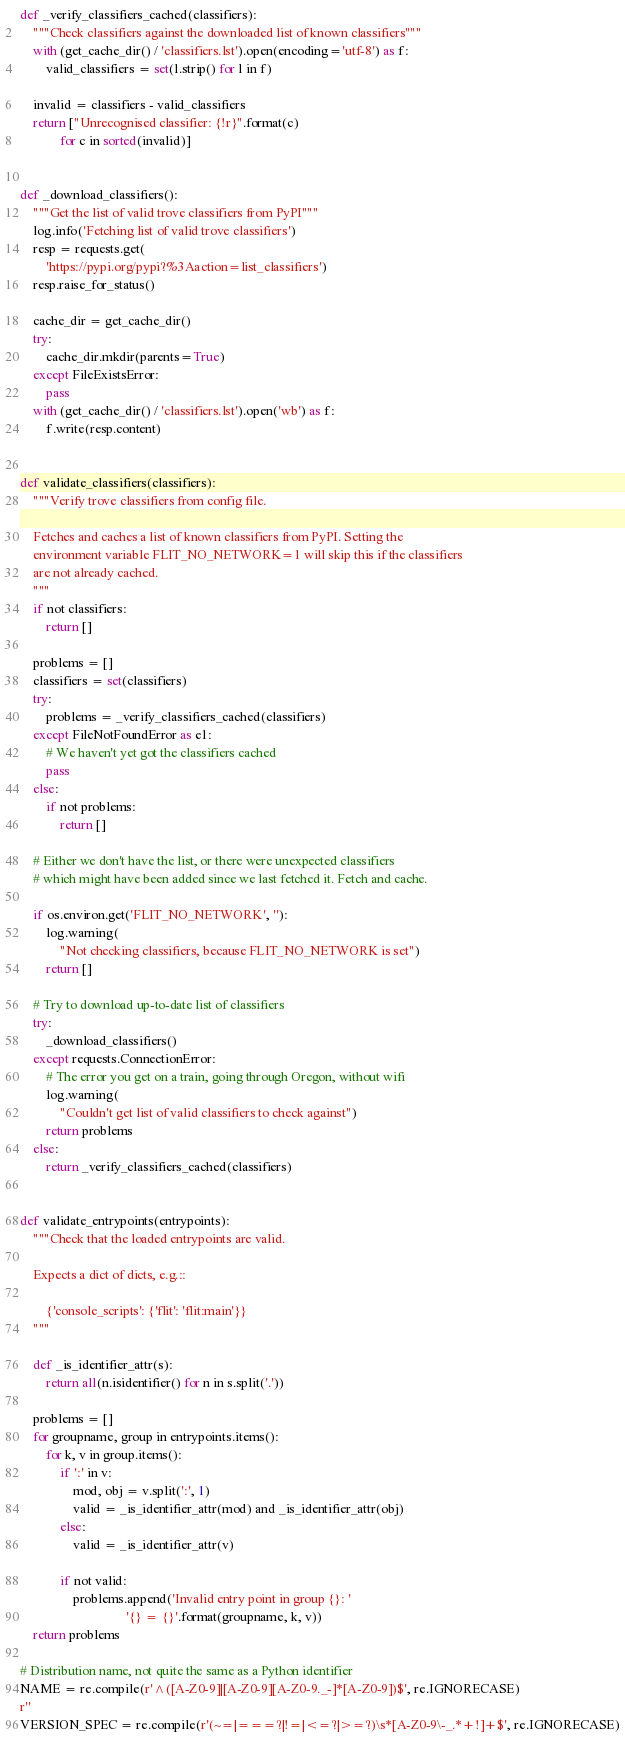Convert code to text. <code><loc_0><loc_0><loc_500><loc_500><_Python_>def _verify_classifiers_cached(classifiers):
    """Check classifiers against the downloaded list of known classifiers"""
    with (get_cache_dir() / 'classifiers.lst').open(encoding='utf-8') as f:
        valid_classifiers = set(l.strip() for l in f)

    invalid = classifiers - valid_classifiers
    return ["Unrecognised classifier: {!r}".format(c)
            for c in sorted(invalid)]


def _download_classifiers():
    """Get the list of valid trove classifiers from PyPI"""
    log.info('Fetching list of valid trove classifiers')
    resp = requests.get(
        'https://pypi.org/pypi?%3Aaction=list_classifiers')
    resp.raise_for_status()

    cache_dir = get_cache_dir()
    try:
        cache_dir.mkdir(parents=True)
    except FileExistsError:
        pass
    with (get_cache_dir() / 'classifiers.lst').open('wb') as f:
        f.write(resp.content)


def validate_classifiers(classifiers):
    """Verify trove classifiers from config file.

    Fetches and caches a list of known classifiers from PyPI. Setting the
    environment variable FLIT_NO_NETWORK=1 will skip this if the classifiers
    are not already cached.
    """
    if not classifiers:
        return []

    problems = []
    classifiers = set(classifiers)
    try:
        problems = _verify_classifiers_cached(classifiers)
    except FileNotFoundError as e1:
        # We haven't yet got the classifiers cached
        pass
    else:
        if not problems:
            return []

    # Either we don't have the list, or there were unexpected classifiers
    # which might have been added since we last fetched it. Fetch and cache.

    if os.environ.get('FLIT_NO_NETWORK', ''):
        log.warning(
            "Not checking classifiers, because FLIT_NO_NETWORK is set")
        return []

    # Try to download up-to-date list of classifiers
    try:
        _download_classifiers()
    except requests.ConnectionError:
        # The error you get on a train, going through Oregon, without wifi
        log.warning(
            "Couldn't get list of valid classifiers to check against")
        return problems
    else:
        return _verify_classifiers_cached(classifiers)


def validate_entrypoints(entrypoints):
    """Check that the loaded entrypoints are valid.

    Expects a dict of dicts, e.g.::

        {'console_scripts': {'flit': 'flit:main'}}
    """

    def _is_identifier_attr(s):
        return all(n.isidentifier() for n in s.split('.'))

    problems = []
    for groupname, group in entrypoints.items():
        for k, v in group.items():
            if ':' in v:
                mod, obj = v.split(':', 1)
                valid = _is_identifier_attr(mod) and _is_identifier_attr(obj)
            else:
                valid = _is_identifier_attr(v)

            if not valid:
                problems.append('Invalid entry point in group {}: '
                                '{} = {}'.format(groupname, k, v))
    return problems

# Distribution name, not quite the same as a Python identifier
NAME = re.compile(r'^([A-Z0-9]|[A-Z0-9][A-Z0-9._-]*[A-Z0-9])$', re.IGNORECASE)
r''
VERSION_SPEC = re.compile(r'(~=|===?|!=|<=?|>=?)\s*[A-Z0-9\-_.*+!]+$', re.IGNORECASE)</code> 